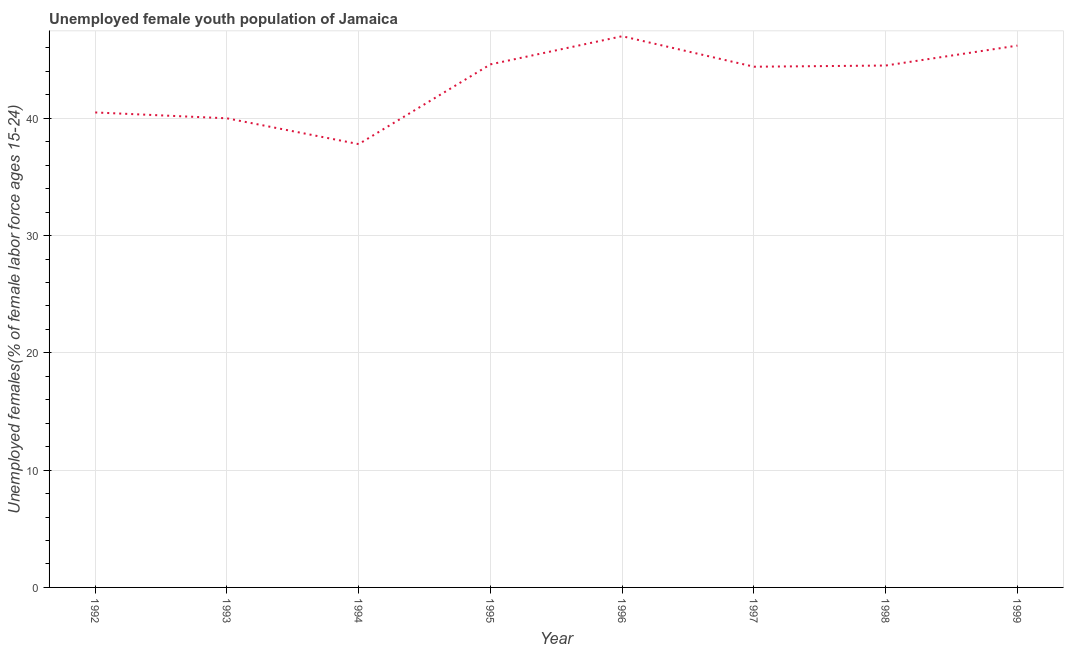Across all years, what is the minimum unemployed female youth?
Provide a succinct answer. 37.8. In which year was the unemployed female youth minimum?
Provide a succinct answer. 1994. What is the sum of the unemployed female youth?
Keep it short and to the point. 345. What is the difference between the unemployed female youth in 1992 and 1999?
Give a very brief answer. -5.7. What is the average unemployed female youth per year?
Give a very brief answer. 43.12. What is the median unemployed female youth?
Give a very brief answer. 44.45. In how many years, is the unemployed female youth greater than 6 %?
Offer a terse response. 8. Do a majority of the years between 1999 and 1996 (inclusive) have unemployed female youth greater than 16 %?
Your answer should be very brief. Yes. What is the ratio of the unemployed female youth in 1996 to that in 1997?
Your response must be concise. 1.06. Is the difference between the unemployed female youth in 1994 and 1998 greater than the difference between any two years?
Your answer should be very brief. No. What is the difference between the highest and the second highest unemployed female youth?
Your response must be concise. 0.8. Is the sum of the unemployed female youth in 1996 and 1997 greater than the maximum unemployed female youth across all years?
Give a very brief answer. Yes. What is the difference between the highest and the lowest unemployed female youth?
Make the answer very short. 9.2. How many years are there in the graph?
Give a very brief answer. 8. What is the difference between two consecutive major ticks on the Y-axis?
Provide a succinct answer. 10. Does the graph contain any zero values?
Your answer should be compact. No. What is the title of the graph?
Make the answer very short. Unemployed female youth population of Jamaica. What is the label or title of the X-axis?
Offer a very short reply. Year. What is the label or title of the Y-axis?
Your answer should be compact. Unemployed females(% of female labor force ages 15-24). What is the Unemployed females(% of female labor force ages 15-24) of 1992?
Offer a very short reply. 40.5. What is the Unemployed females(% of female labor force ages 15-24) in 1993?
Your answer should be compact. 40. What is the Unemployed females(% of female labor force ages 15-24) of 1994?
Your answer should be compact. 37.8. What is the Unemployed females(% of female labor force ages 15-24) in 1995?
Offer a very short reply. 44.6. What is the Unemployed females(% of female labor force ages 15-24) of 1996?
Provide a succinct answer. 47. What is the Unemployed females(% of female labor force ages 15-24) in 1997?
Keep it short and to the point. 44.4. What is the Unemployed females(% of female labor force ages 15-24) of 1998?
Ensure brevity in your answer.  44.5. What is the Unemployed females(% of female labor force ages 15-24) in 1999?
Keep it short and to the point. 46.2. What is the difference between the Unemployed females(% of female labor force ages 15-24) in 1992 and 1993?
Your response must be concise. 0.5. What is the difference between the Unemployed females(% of female labor force ages 15-24) in 1992 and 1995?
Keep it short and to the point. -4.1. What is the difference between the Unemployed females(% of female labor force ages 15-24) in 1992 and 1998?
Your response must be concise. -4. What is the difference between the Unemployed females(% of female labor force ages 15-24) in 1992 and 1999?
Give a very brief answer. -5.7. What is the difference between the Unemployed females(% of female labor force ages 15-24) in 1993 and 1995?
Your response must be concise. -4.6. What is the difference between the Unemployed females(% of female labor force ages 15-24) in 1993 and 1997?
Offer a very short reply. -4.4. What is the difference between the Unemployed females(% of female labor force ages 15-24) in 1993 and 1998?
Keep it short and to the point. -4.5. What is the difference between the Unemployed females(% of female labor force ages 15-24) in 1994 and 1997?
Give a very brief answer. -6.6. What is the difference between the Unemployed females(% of female labor force ages 15-24) in 1994 and 1998?
Ensure brevity in your answer.  -6.7. What is the difference between the Unemployed females(% of female labor force ages 15-24) in 1995 and 1996?
Your answer should be compact. -2.4. What is the difference between the Unemployed females(% of female labor force ages 15-24) in 1996 and 1999?
Make the answer very short. 0.8. What is the difference between the Unemployed females(% of female labor force ages 15-24) in 1997 and 1998?
Ensure brevity in your answer.  -0.1. What is the difference between the Unemployed females(% of female labor force ages 15-24) in 1998 and 1999?
Provide a succinct answer. -1.7. What is the ratio of the Unemployed females(% of female labor force ages 15-24) in 1992 to that in 1993?
Your answer should be very brief. 1.01. What is the ratio of the Unemployed females(% of female labor force ages 15-24) in 1992 to that in 1994?
Offer a terse response. 1.07. What is the ratio of the Unemployed females(% of female labor force ages 15-24) in 1992 to that in 1995?
Keep it short and to the point. 0.91. What is the ratio of the Unemployed females(% of female labor force ages 15-24) in 1992 to that in 1996?
Your answer should be very brief. 0.86. What is the ratio of the Unemployed females(% of female labor force ages 15-24) in 1992 to that in 1997?
Provide a short and direct response. 0.91. What is the ratio of the Unemployed females(% of female labor force ages 15-24) in 1992 to that in 1998?
Offer a terse response. 0.91. What is the ratio of the Unemployed females(% of female labor force ages 15-24) in 1992 to that in 1999?
Your answer should be very brief. 0.88. What is the ratio of the Unemployed females(% of female labor force ages 15-24) in 1993 to that in 1994?
Offer a terse response. 1.06. What is the ratio of the Unemployed females(% of female labor force ages 15-24) in 1993 to that in 1995?
Give a very brief answer. 0.9. What is the ratio of the Unemployed females(% of female labor force ages 15-24) in 1993 to that in 1996?
Your response must be concise. 0.85. What is the ratio of the Unemployed females(% of female labor force ages 15-24) in 1993 to that in 1997?
Provide a short and direct response. 0.9. What is the ratio of the Unemployed females(% of female labor force ages 15-24) in 1993 to that in 1998?
Your answer should be compact. 0.9. What is the ratio of the Unemployed females(% of female labor force ages 15-24) in 1993 to that in 1999?
Provide a succinct answer. 0.87. What is the ratio of the Unemployed females(% of female labor force ages 15-24) in 1994 to that in 1995?
Your answer should be compact. 0.85. What is the ratio of the Unemployed females(% of female labor force ages 15-24) in 1994 to that in 1996?
Your answer should be compact. 0.8. What is the ratio of the Unemployed females(% of female labor force ages 15-24) in 1994 to that in 1997?
Provide a succinct answer. 0.85. What is the ratio of the Unemployed females(% of female labor force ages 15-24) in 1994 to that in 1998?
Ensure brevity in your answer.  0.85. What is the ratio of the Unemployed females(% of female labor force ages 15-24) in 1994 to that in 1999?
Your answer should be compact. 0.82. What is the ratio of the Unemployed females(% of female labor force ages 15-24) in 1995 to that in 1996?
Your answer should be compact. 0.95. What is the ratio of the Unemployed females(% of female labor force ages 15-24) in 1995 to that in 1998?
Keep it short and to the point. 1. What is the ratio of the Unemployed females(% of female labor force ages 15-24) in 1996 to that in 1997?
Your answer should be very brief. 1.06. What is the ratio of the Unemployed females(% of female labor force ages 15-24) in 1996 to that in 1998?
Your answer should be very brief. 1.06. What is the ratio of the Unemployed females(% of female labor force ages 15-24) in 1997 to that in 1998?
Keep it short and to the point. 1. 